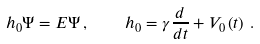Convert formula to latex. <formula><loc_0><loc_0><loc_500><loc_500>h _ { 0 } \Psi = E \Psi \, , \quad h _ { 0 } = \gamma \frac { d } { d t } + V _ { 0 } \left ( t \right ) \, .</formula> 